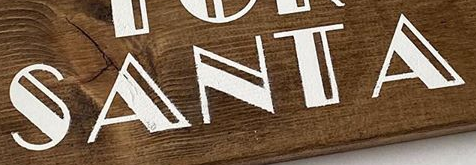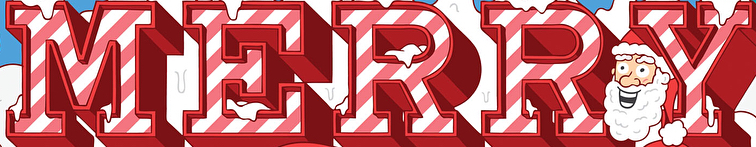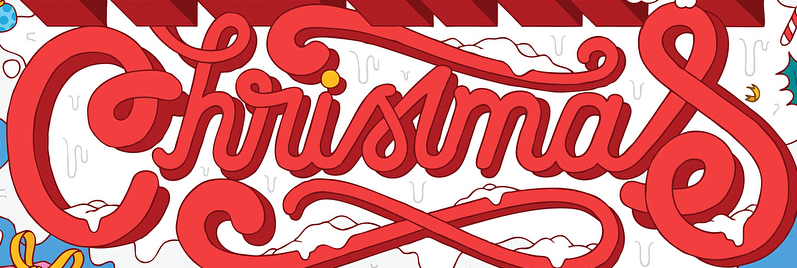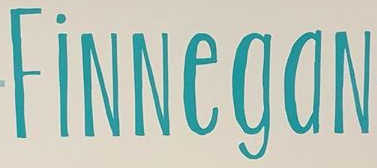What words can you see in these images in sequence, separated by a semicolon? SANTA; MERRY; Christmas; FiNNegaN 